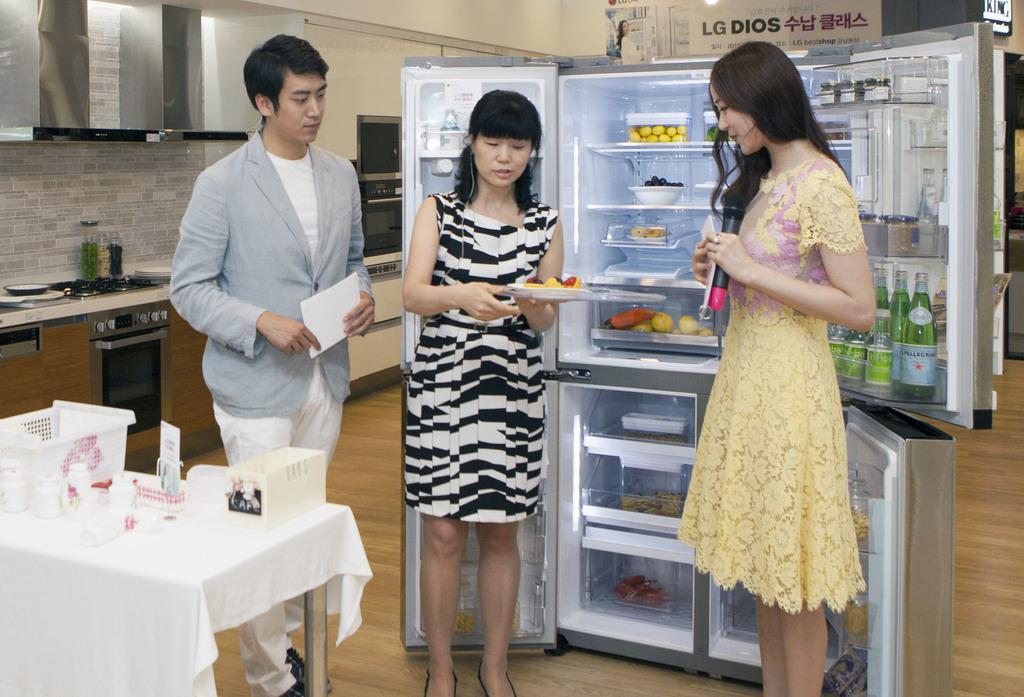Can you describe this image briefly? This 3 persons are standing in-front of a fridge. In this fridge there are bottles, fruits, bowl, container and things. This is a stove with oven. On this table there is a basket and box. This man is holding a paper, this woman is holding a plate, this woman is holding a mic. Far there are posters on wall. 